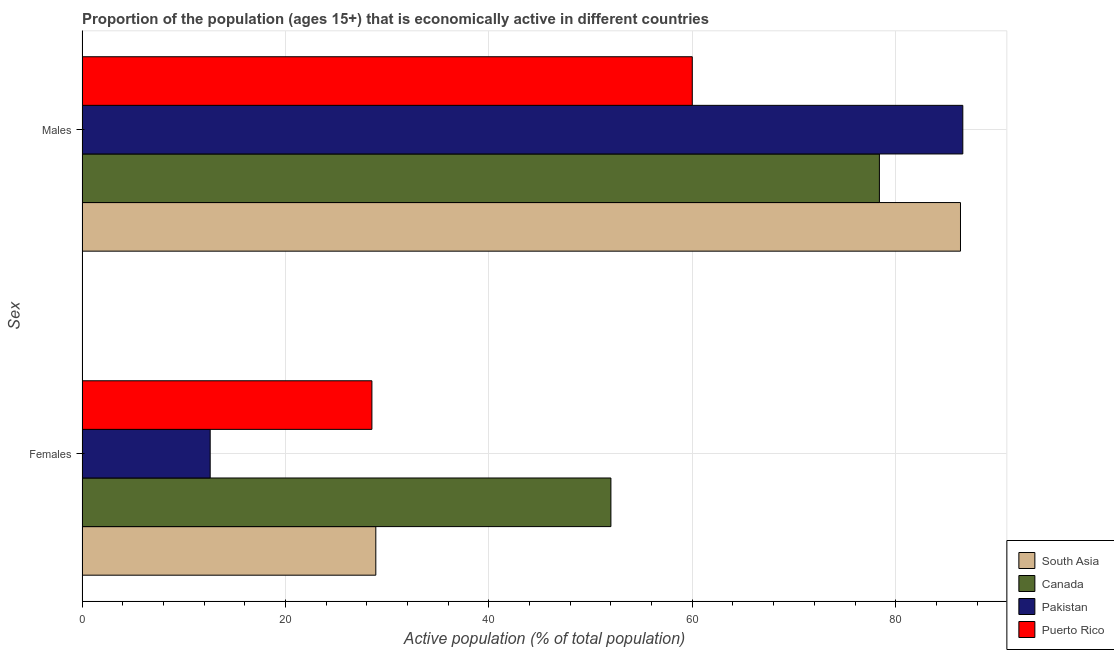How many different coloured bars are there?
Provide a succinct answer. 4. Are the number of bars per tick equal to the number of legend labels?
Ensure brevity in your answer.  Yes. What is the label of the 2nd group of bars from the top?
Ensure brevity in your answer.  Females. What is the percentage of economically active male population in Puerto Rico?
Your answer should be very brief. 60. Across all countries, what is the minimum percentage of economically active female population?
Provide a succinct answer. 12.6. In which country was the percentage of economically active female population maximum?
Your response must be concise. Canada. What is the total percentage of economically active male population in the graph?
Your answer should be very brief. 311.37. What is the difference between the percentage of economically active female population in Pakistan and that in Puerto Rico?
Offer a terse response. -15.9. What is the difference between the percentage of economically active female population in South Asia and the percentage of economically active male population in Puerto Rico?
Provide a short and direct response. -31.12. What is the average percentage of economically active female population per country?
Provide a short and direct response. 30.5. What is the difference between the percentage of economically active male population and percentage of economically active female population in Pakistan?
Give a very brief answer. 74. In how many countries, is the percentage of economically active male population greater than 72 %?
Give a very brief answer. 3. What is the ratio of the percentage of economically active male population in Puerto Rico to that in South Asia?
Give a very brief answer. 0.69. In how many countries, is the percentage of economically active female population greater than the average percentage of economically active female population taken over all countries?
Provide a short and direct response. 1. What does the 1st bar from the top in Males represents?
Offer a terse response. Puerto Rico. How many bars are there?
Your answer should be very brief. 8. How many countries are there in the graph?
Offer a very short reply. 4. How are the legend labels stacked?
Your response must be concise. Vertical. What is the title of the graph?
Make the answer very short. Proportion of the population (ages 15+) that is economically active in different countries. What is the label or title of the X-axis?
Provide a short and direct response. Active population (% of total population). What is the label or title of the Y-axis?
Ensure brevity in your answer.  Sex. What is the Active population (% of total population) in South Asia in Females?
Make the answer very short. 28.88. What is the Active population (% of total population) of Canada in Females?
Give a very brief answer. 52. What is the Active population (% of total population) of Pakistan in Females?
Give a very brief answer. 12.6. What is the Active population (% of total population) of South Asia in Males?
Your answer should be very brief. 86.37. What is the Active population (% of total population) in Canada in Males?
Make the answer very short. 78.4. What is the Active population (% of total population) in Pakistan in Males?
Make the answer very short. 86.6. What is the Active population (% of total population) in Puerto Rico in Males?
Provide a succinct answer. 60. Across all Sex, what is the maximum Active population (% of total population) in South Asia?
Keep it short and to the point. 86.37. Across all Sex, what is the maximum Active population (% of total population) in Canada?
Provide a short and direct response. 78.4. Across all Sex, what is the maximum Active population (% of total population) of Pakistan?
Your answer should be very brief. 86.6. Across all Sex, what is the minimum Active population (% of total population) of South Asia?
Your answer should be very brief. 28.88. Across all Sex, what is the minimum Active population (% of total population) in Pakistan?
Offer a terse response. 12.6. What is the total Active population (% of total population) of South Asia in the graph?
Your response must be concise. 115.26. What is the total Active population (% of total population) of Canada in the graph?
Offer a very short reply. 130.4. What is the total Active population (% of total population) in Pakistan in the graph?
Provide a succinct answer. 99.2. What is the total Active population (% of total population) in Puerto Rico in the graph?
Offer a very short reply. 88.5. What is the difference between the Active population (% of total population) in South Asia in Females and that in Males?
Offer a terse response. -57.49. What is the difference between the Active population (% of total population) in Canada in Females and that in Males?
Give a very brief answer. -26.4. What is the difference between the Active population (% of total population) of Pakistan in Females and that in Males?
Your answer should be very brief. -74. What is the difference between the Active population (% of total population) in Puerto Rico in Females and that in Males?
Keep it short and to the point. -31.5. What is the difference between the Active population (% of total population) of South Asia in Females and the Active population (% of total population) of Canada in Males?
Your response must be concise. -49.52. What is the difference between the Active population (% of total population) in South Asia in Females and the Active population (% of total population) in Pakistan in Males?
Your answer should be compact. -57.72. What is the difference between the Active population (% of total population) of South Asia in Females and the Active population (% of total population) of Puerto Rico in Males?
Keep it short and to the point. -31.11. What is the difference between the Active population (% of total population) in Canada in Females and the Active population (% of total population) in Pakistan in Males?
Your answer should be compact. -34.6. What is the difference between the Active population (% of total population) of Canada in Females and the Active population (% of total population) of Puerto Rico in Males?
Ensure brevity in your answer.  -8. What is the difference between the Active population (% of total population) of Pakistan in Females and the Active population (% of total population) of Puerto Rico in Males?
Keep it short and to the point. -47.4. What is the average Active population (% of total population) of South Asia per Sex?
Your response must be concise. 57.63. What is the average Active population (% of total population) of Canada per Sex?
Your answer should be very brief. 65.2. What is the average Active population (% of total population) in Pakistan per Sex?
Offer a very short reply. 49.6. What is the average Active population (% of total population) in Puerto Rico per Sex?
Your answer should be compact. 44.25. What is the difference between the Active population (% of total population) in South Asia and Active population (% of total population) in Canada in Females?
Your response must be concise. -23.11. What is the difference between the Active population (% of total population) in South Asia and Active population (% of total population) in Pakistan in Females?
Make the answer very short. 16.29. What is the difference between the Active population (% of total population) of South Asia and Active population (% of total population) of Puerto Rico in Females?
Your response must be concise. 0.39. What is the difference between the Active population (% of total population) in Canada and Active population (% of total population) in Pakistan in Females?
Your answer should be compact. 39.4. What is the difference between the Active population (% of total population) of Pakistan and Active population (% of total population) of Puerto Rico in Females?
Provide a succinct answer. -15.9. What is the difference between the Active population (% of total population) in South Asia and Active population (% of total population) in Canada in Males?
Your answer should be compact. 7.97. What is the difference between the Active population (% of total population) of South Asia and Active population (% of total population) of Pakistan in Males?
Your answer should be compact. -0.23. What is the difference between the Active population (% of total population) of South Asia and Active population (% of total population) of Puerto Rico in Males?
Offer a terse response. 26.37. What is the difference between the Active population (% of total population) of Pakistan and Active population (% of total population) of Puerto Rico in Males?
Keep it short and to the point. 26.6. What is the ratio of the Active population (% of total population) of South Asia in Females to that in Males?
Provide a succinct answer. 0.33. What is the ratio of the Active population (% of total population) in Canada in Females to that in Males?
Offer a very short reply. 0.66. What is the ratio of the Active population (% of total population) in Pakistan in Females to that in Males?
Your response must be concise. 0.15. What is the ratio of the Active population (% of total population) of Puerto Rico in Females to that in Males?
Keep it short and to the point. 0.47. What is the difference between the highest and the second highest Active population (% of total population) of South Asia?
Provide a succinct answer. 57.49. What is the difference between the highest and the second highest Active population (% of total population) in Canada?
Provide a succinct answer. 26.4. What is the difference between the highest and the second highest Active population (% of total population) of Pakistan?
Your answer should be very brief. 74. What is the difference between the highest and the second highest Active population (% of total population) in Puerto Rico?
Your answer should be compact. 31.5. What is the difference between the highest and the lowest Active population (% of total population) in South Asia?
Offer a terse response. 57.49. What is the difference between the highest and the lowest Active population (% of total population) in Canada?
Provide a succinct answer. 26.4. What is the difference between the highest and the lowest Active population (% of total population) in Pakistan?
Make the answer very short. 74. What is the difference between the highest and the lowest Active population (% of total population) in Puerto Rico?
Provide a short and direct response. 31.5. 